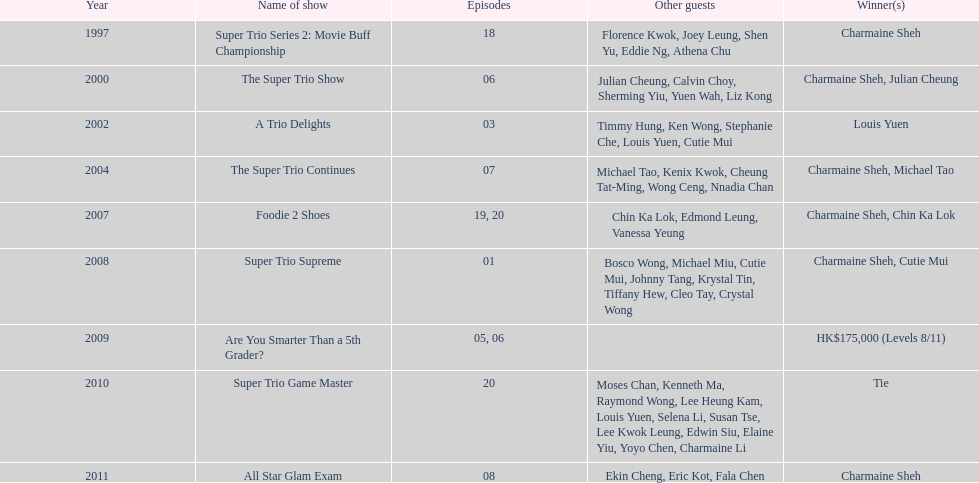What year was the only year were a tie occurred? 2010. 